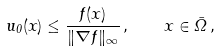<formula> <loc_0><loc_0><loc_500><loc_500>u _ { 0 } ( x ) \leq \frac { f ( x ) } { \| \nabla f \| _ { \infty } } \, , \quad x \in \bar { \Omega } \, ,</formula> 